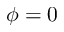<formula> <loc_0><loc_0><loc_500><loc_500>\phi = 0</formula> 